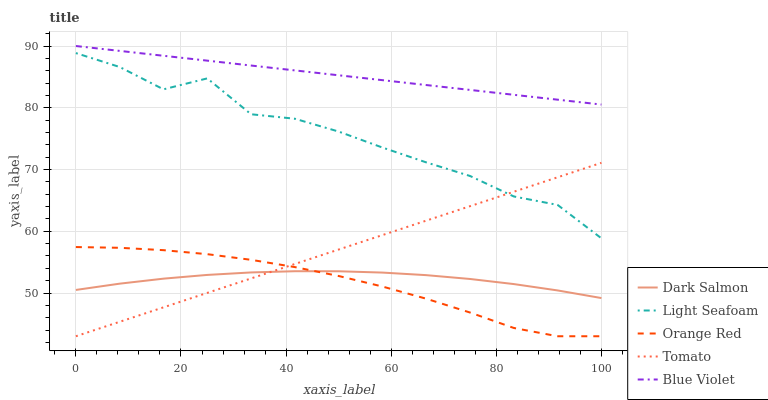Does Light Seafoam have the minimum area under the curve?
Answer yes or no. No. Does Light Seafoam have the maximum area under the curve?
Answer yes or no. No. Is Dark Salmon the smoothest?
Answer yes or no. No. Is Dark Salmon the roughest?
Answer yes or no. No. Does Light Seafoam have the lowest value?
Answer yes or no. No. Does Light Seafoam have the highest value?
Answer yes or no. No. Is Tomato less than Blue Violet?
Answer yes or no. Yes. Is Light Seafoam greater than Orange Red?
Answer yes or no. Yes. Does Tomato intersect Blue Violet?
Answer yes or no. No. 